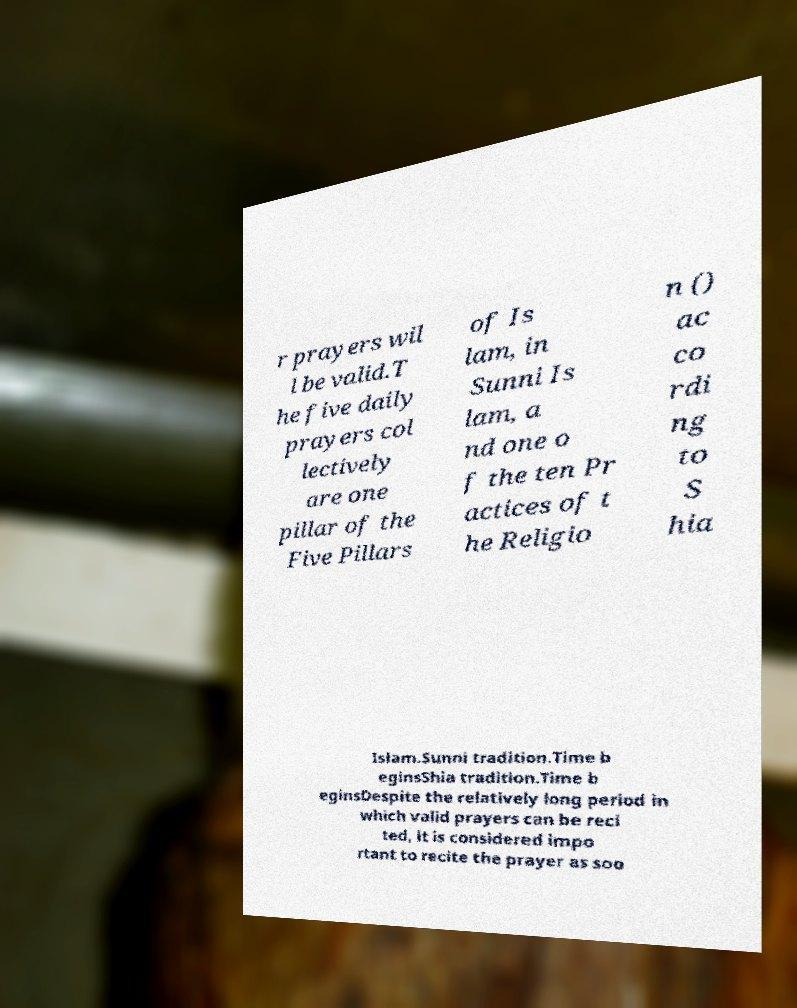Please identify and transcribe the text found in this image. r prayers wil l be valid.T he five daily prayers col lectively are one pillar of the Five Pillars of Is lam, in Sunni Is lam, a nd one o f the ten Pr actices of t he Religio n () ac co rdi ng to S hia Islam.Sunni tradition.Time b eginsShia tradition.Time b eginsDespite the relatively long period in which valid prayers can be reci ted, it is considered impo rtant to recite the prayer as soo 